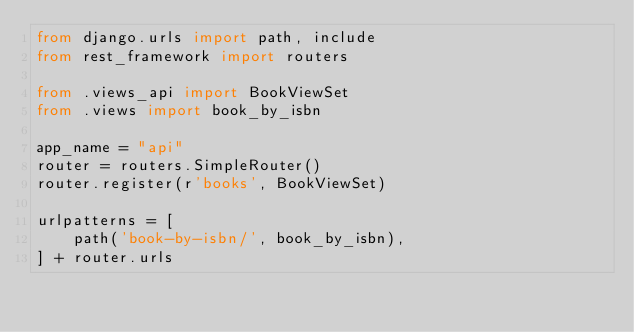Convert code to text. <code><loc_0><loc_0><loc_500><loc_500><_Python_>from django.urls import path, include
from rest_framework import routers

from .views_api import BookViewSet
from .views import book_by_isbn

app_name = "api"
router = routers.SimpleRouter()
router.register(r'books', BookViewSet)

urlpatterns = [
    path('book-by-isbn/', book_by_isbn),
] + router.urls
</code> 